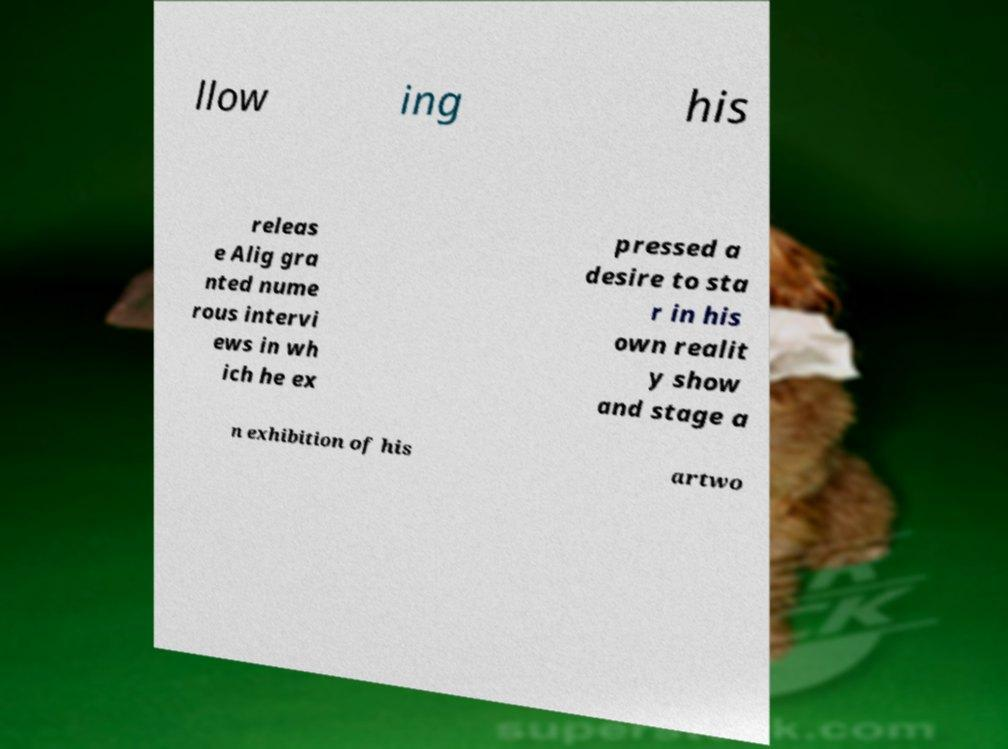What messages or text are displayed in this image? I need them in a readable, typed format. llow ing his releas e Alig gra nted nume rous intervi ews in wh ich he ex pressed a desire to sta r in his own realit y show and stage a n exhibition of his artwo 